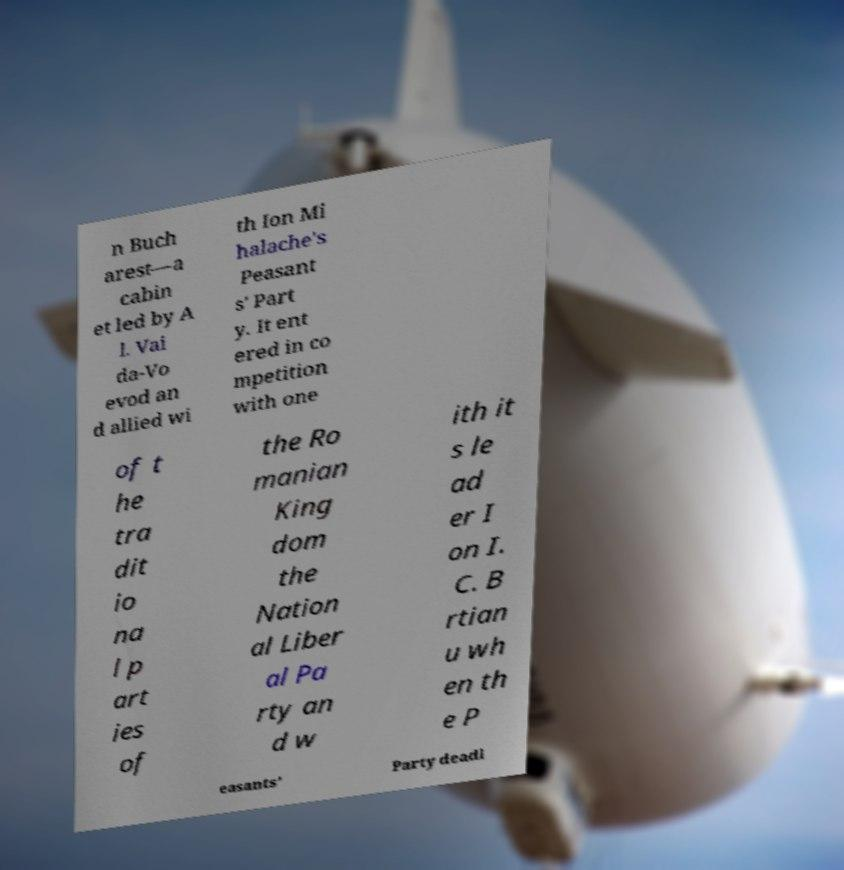For documentation purposes, I need the text within this image transcribed. Could you provide that? n Buch arest—a cabin et led by A l. Vai da-Vo evod an d allied wi th Ion Mi halache's Peasant s' Part y. It ent ered in co mpetition with one of t he tra dit io na l p art ies of the Ro manian King dom the Nation al Liber al Pa rty an d w ith it s le ad er I on I. C. B rtian u wh en th e P easants' Party deadl 